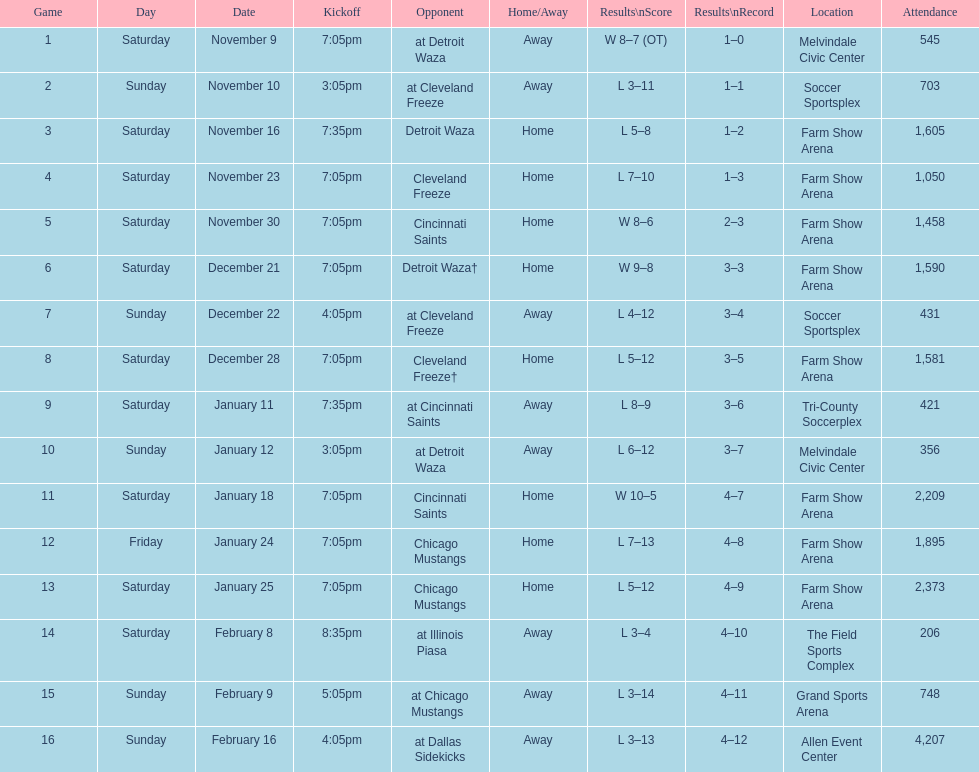What was the location before tri-county soccerplex? Farm Show Arena. Parse the table in full. {'header': ['Game', 'Day', 'Date', 'Kickoff', 'Opponent', 'Home/Away', 'Results\\nScore', 'Results\\nRecord', 'Location', 'Attendance'], 'rows': [['1', 'Saturday', 'November 9', '7:05pm', 'at Detroit Waza', 'Away', 'W 8–7 (OT)', '1–0', 'Melvindale Civic Center', '545'], ['2', 'Sunday', 'November 10', '3:05pm', 'at Cleveland Freeze', 'Away', 'L 3–11', '1–1', 'Soccer Sportsplex', '703'], ['3', 'Saturday', 'November 16', '7:35pm', 'Detroit Waza', 'Home', 'L 5–8', '1–2', 'Farm Show Arena', '1,605'], ['4', 'Saturday', 'November 23', '7:05pm', 'Cleveland Freeze', 'Home', 'L 7–10', '1–3', 'Farm Show Arena', '1,050'], ['5', 'Saturday', 'November 30', '7:05pm', 'Cincinnati Saints', 'Home', 'W 8–6', '2–3', 'Farm Show Arena', '1,458'], ['6', 'Saturday', 'December 21', '7:05pm', 'Detroit Waza†', 'Home', 'W 9–8', '3–3', 'Farm Show Arena', '1,590'], ['7', 'Sunday', 'December 22', '4:05pm', 'at Cleveland Freeze', 'Away', 'L 4–12', '3–4', 'Soccer Sportsplex', '431'], ['8', 'Saturday', 'December 28', '7:05pm', 'Cleveland Freeze†', 'Home', 'L 5–12', '3–5', 'Farm Show Arena', '1,581'], ['9', 'Saturday', 'January 11', '7:35pm', 'at Cincinnati Saints', 'Away', 'L 8–9', '3–6', 'Tri-County Soccerplex', '421'], ['10', 'Sunday', 'January 12', '3:05pm', 'at Detroit Waza', 'Away', 'L 6–12', '3–7', 'Melvindale Civic Center', '356'], ['11', 'Saturday', 'January 18', '7:05pm', 'Cincinnati Saints', 'Home', 'W 10–5', '4–7', 'Farm Show Arena', '2,209'], ['12', 'Friday', 'January 24', '7:05pm', 'Chicago Mustangs', 'Home', 'L 7–13', '4–8', 'Farm Show Arena', '1,895'], ['13', 'Saturday', 'January 25', '7:05pm', 'Chicago Mustangs', 'Home', 'L 5–12', '4–9', 'Farm Show Arena', '2,373'], ['14', 'Saturday', 'February 8', '8:35pm', 'at Illinois Piasa', 'Away', 'L 3–4', '4–10', 'The Field Sports Complex', '206'], ['15', 'Sunday', 'February 9', '5:05pm', 'at Chicago Mustangs', 'Away', 'L 3–14', '4–11', 'Grand Sports Arena', '748'], ['16', 'Sunday', 'February 16', '4:05pm', 'at Dallas Sidekicks', 'Away', 'L 3–13', '4–12', 'Allen Event Center', '4,207']]} 